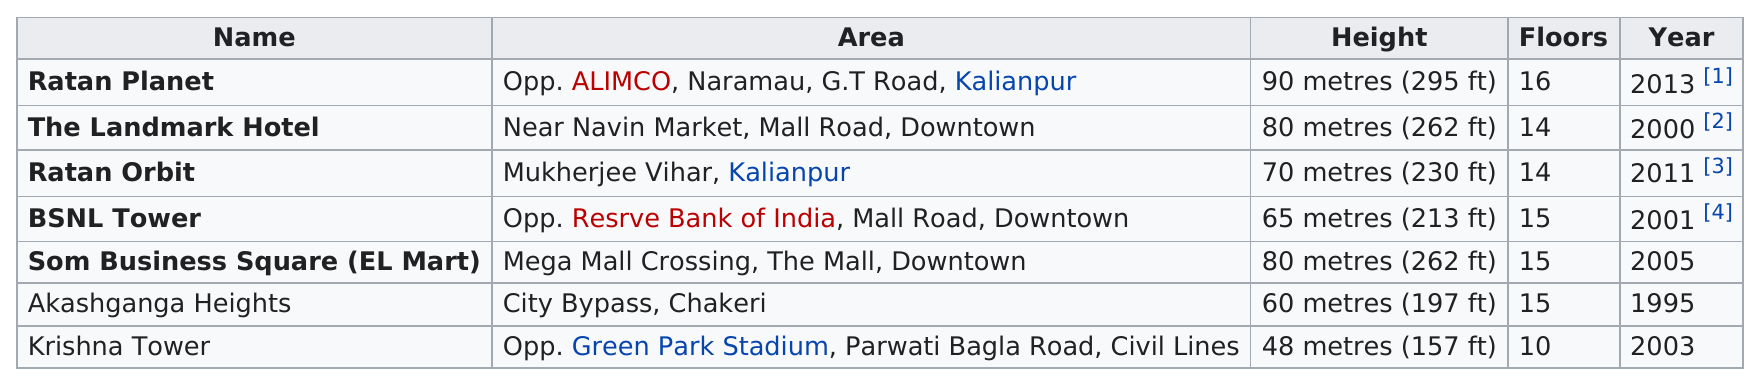Outline some significant characteristics in this image. The buildings that have the same number of floors as at least two others are BSNL Tower, Som Business Square (EL Mart), and Akashganga Heights. Akashganga Heights and Som Business Square both have the same number of floors as the BSNL Tower. Both the Landmark Hotel and Ratan Orbit have a total of 14 floors. The Krishna Tower had the least number of floors among all buildings. Out of the total number of buildings, approximately 3 belong to the downtown area. 